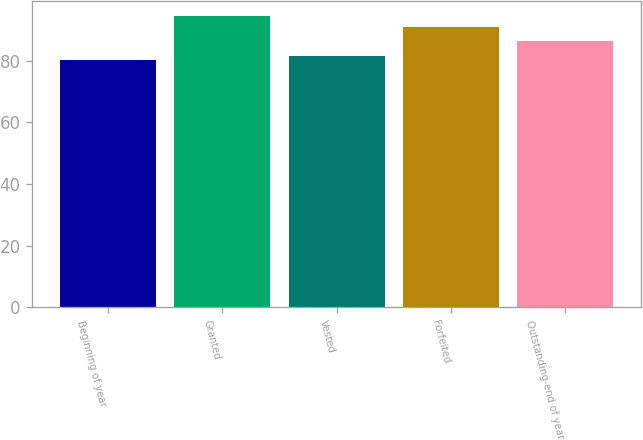Convert chart to OTSL. <chart><loc_0><loc_0><loc_500><loc_500><bar_chart><fcel>Beginning of year<fcel>Granted<fcel>Vested<fcel>Forfeited<fcel>Outstanding-end of year<nl><fcel>80.08<fcel>94.63<fcel>81.53<fcel>90.85<fcel>86.47<nl></chart> 